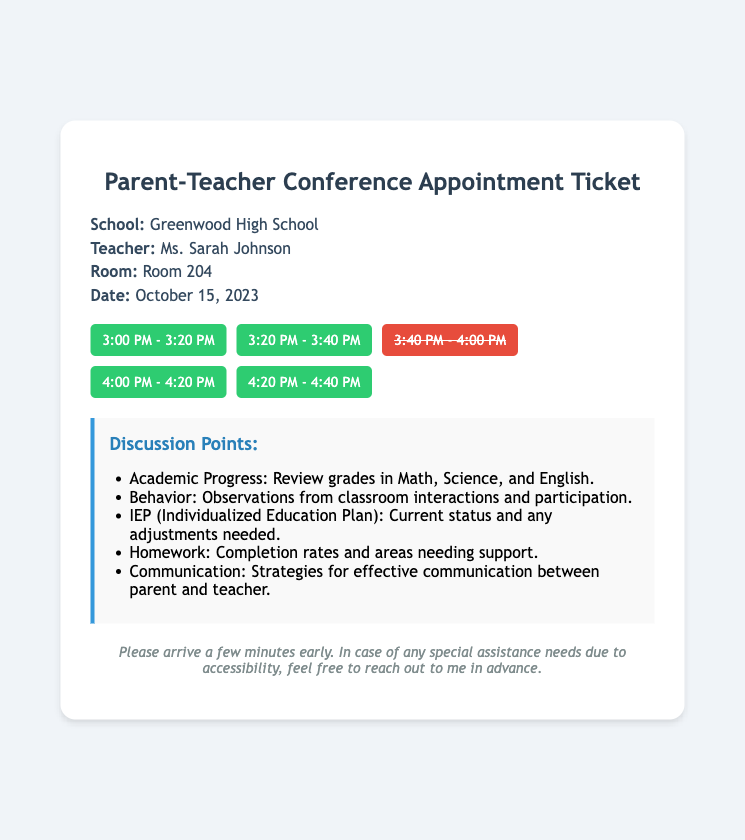what is the name of the teacher? The name of the teacher is clearly stated in the document.
Answer: Ms. Sarah Johnson what is the date of the conference? The date of the conference is specified in the document under the date section.
Answer: October 15, 2023 how many available time slots are there? The document mentions several time slots and indicates which are available.
Answer: Four what room is the conference held in? The room number is mentioned in the information section of the document.
Answer: Room 204 what is one of the discussion points? One of the discussion points is listed in a bulleted format in the document.
Answer: Academic Progress: Review grades in Math, Science, and English which time slot is unavailable? The document lists available and unavailable slots, providing the answer directly.
Answer: 3:40 PM - 4:00 PM what is the school’s name? The name of the school is provided in the information section at the beginning of the document.
Answer: Greenwood High School what should parents do if they need special assistance? The document suggests a course of action if special help is needed.
Answer: Reach out to me in advance 